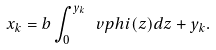<formula> <loc_0><loc_0><loc_500><loc_500>x _ { k } = b \int _ { 0 } ^ { y _ { k } } \ v p h i ( z ) d z + y _ { k } .</formula> 